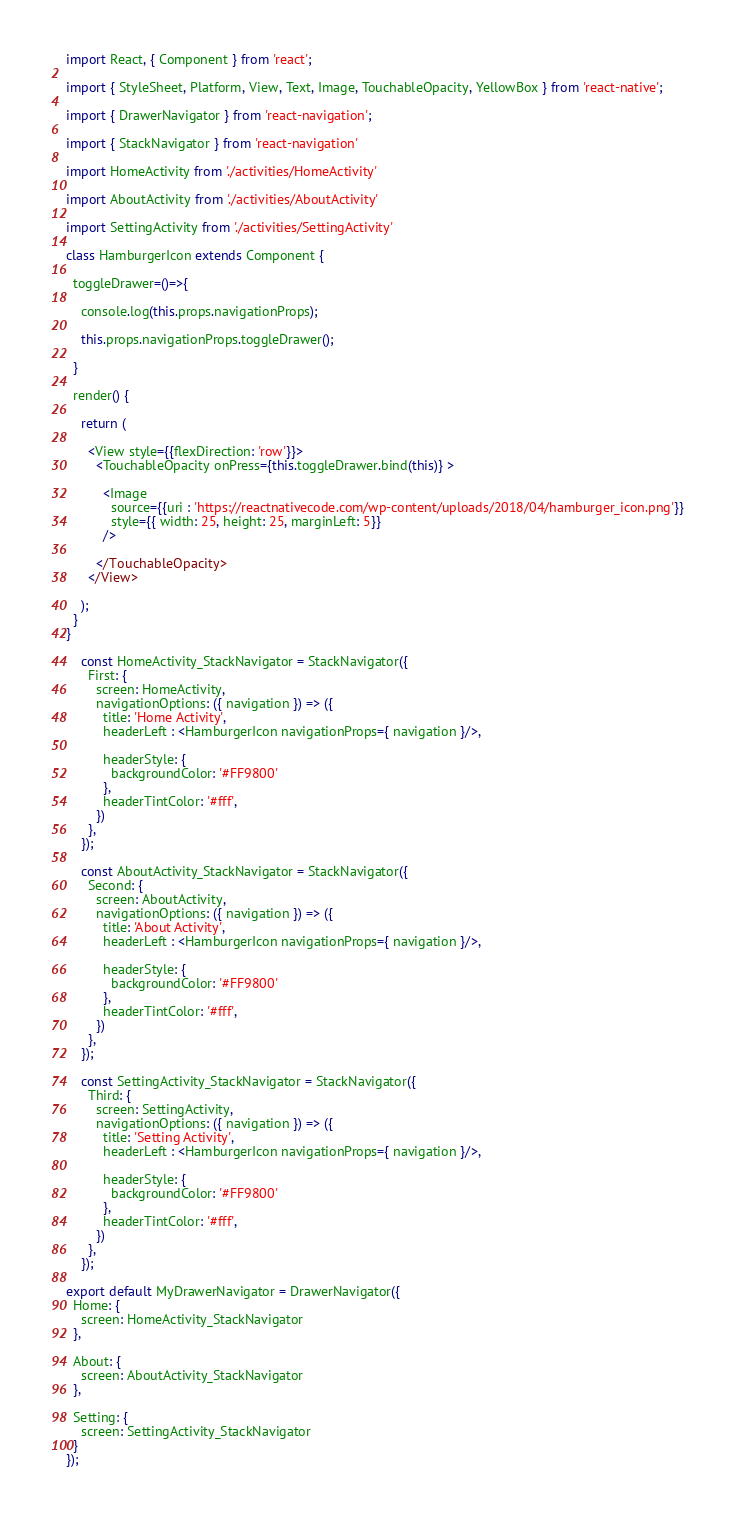<code> <loc_0><loc_0><loc_500><loc_500><_JavaScript_>
import React, { Component } from 'react';
 
import { StyleSheet, Platform, View, Text, Image, TouchableOpacity, YellowBox } from 'react-native';
 
import { DrawerNavigator } from 'react-navigation';
 
import { StackNavigator } from 'react-navigation'

import HomeActivity from './activities/HomeActivity'

import AboutActivity from './activities/AboutActivity'

import SettingActivity from './activities/SettingActivity'
 
class HamburgerIcon extends Component {
 
  toggleDrawer=()=>{
 
    console.log(this.props.navigationProps);
    
    this.props.navigationProps.toggleDrawer();
 
  }
 
  render() {
 
    return (
 
      <View style={{flexDirection: 'row'}}>
        <TouchableOpacity onPress={this.toggleDrawer.bind(this)} >
 
          <Image
            source={{uri : 'https://reactnativecode.com/wp-content/uploads/2018/04/hamburger_icon.png'}}
            style={{ width: 25, height: 25, marginLeft: 5}}
          />
 
        </TouchableOpacity>
      </View>
    
    );
  }
}
 
    const HomeActivity_StackNavigator = StackNavigator({
      First: { 
        screen: HomeActivity, 
        navigationOptions: ({ navigation }) => ({
          title: 'Home Activity',
          headerLeft : <HamburgerIcon navigationProps={ navigation }/>,
 
          headerStyle: {
            backgroundColor: '#FF9800'
          },
          headerTintColor: '#fff',
        })
      },
    });
 
    const AboutActivity_StackNavigator = StackNavigator({
      Second: { 
        screen: AboutActivity, 
        navigationOptions: ({ navigation }) => ({
          title: 'About Activity',
          headerLeft : <HamburgerIcon navigationProps={ navigation }/>,
 
          headerStyle: {
            backgroundColor: '#FF9800'
          },
          headerTintColor: '#fff',
        })
      },
    });
 
    const SettingActivity_StackNavigator = StackNavigator({
      Third: { 
        screen: SettingActivity, 
        navigationOptions: ({ navigation }) => ({
          title: 'Setting Activity',
          headerLeft : <HamburgerIcon navigationProps={ navigation }/>,
 
          headerStyle: {
            backgroundColor: '#FF9800'
          },
          headerTintColor: '#fff',
        })
      },
    });
    
export default MyDrawerNavigator = DrawerNavigator({
  Home: { 
    screen: HomeActivity_StackNavigator
  },
 
  About: {
    screen: AboutActivity_StackNavigator
  },
 
  Setting: { 
    screen: SettingActivity_StackNavigator
  }
});
</code> 